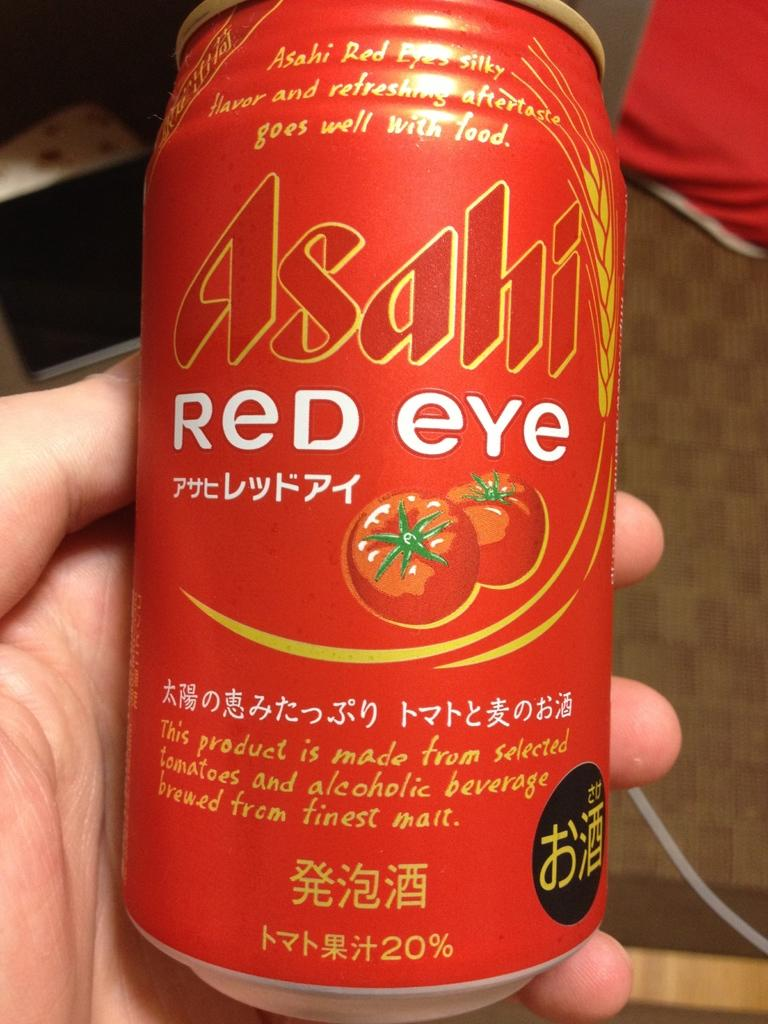<image>
Give a short and clear explanation of the subsequent image. A can of Asahi Red Eye held in a hand. 